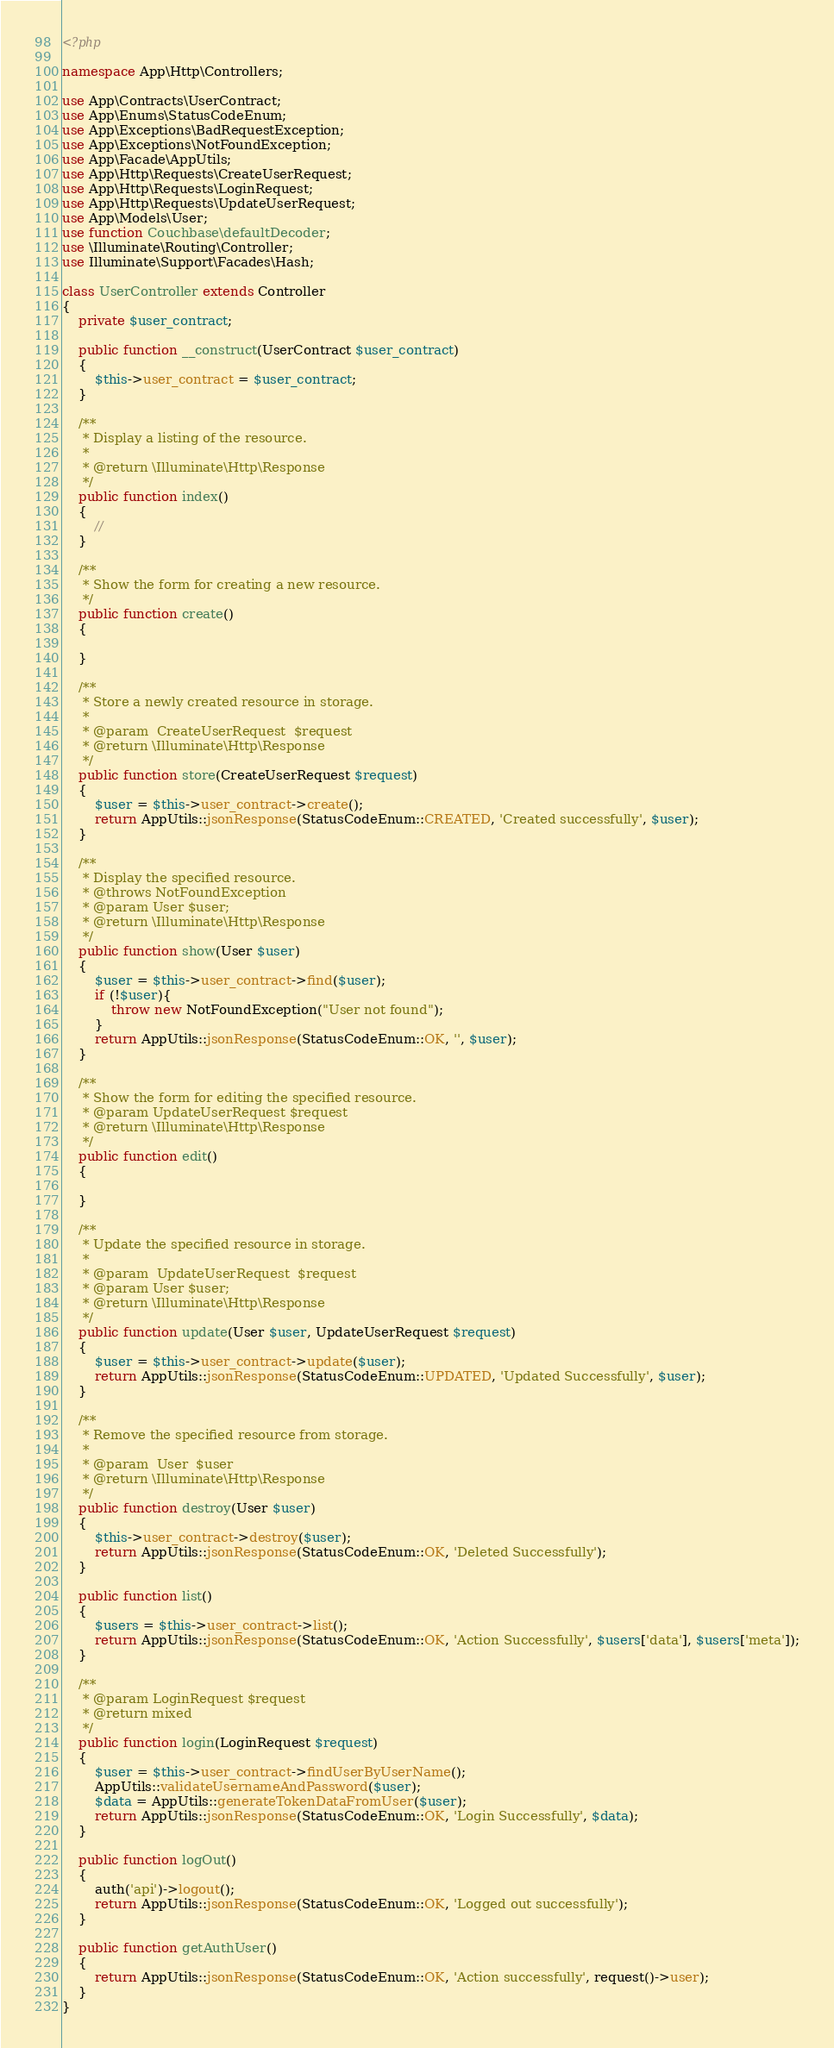Convert code to text. <code><loc_0><loc_0><loc_500><loc_500><_PHP_><?php

namespace App\Http\Controllers;

use App\Contracts\UserContract;
use App\Enums\StatusCodeEnum;
use App\Exceptions\BadRequestException;
use App\Exceptions\NotFoundException;
use App\Facade\AppUtils;
use App\Http\Requests\CreateUserRequest;
use App\Http\Requests\LoginRequest;
use App\Http\Requests\UpdateUserRequest;
use App\Models\User;
use function Couchbase\defaultDecoder;
use \Illuminate\Routing\Controller;
use Illuminate\Support\Facades\Hash;

class UserController extends Controller
{
    private $user_contract;

    public function __construct(UserContract $user_contract)
    {
        $this->user_contract = $user_contract;
    }

    /**
     * Display a listing of the resource.
     *
     * @return \Illuminate\Http\Response
     */
    public function index()
    {
        //
    }

    /**
     * Show the form for creating a new resource.
     */
    public function create()
    {

    }

    /**
     * Store a newly created resource in storage.
     *
     * @param  CreateUserRequest  $request
     * @return \Illuminate\Http\Response
     */
    public function store(CreateUserRequest $request)
    {
        $user = $this->user_contract->create();
        return AppUtils::jsonResponse(StatusCodeEnum::CREATED, 'Created successfully', $user);
    }

    /**
     * Display the specified resource.
     * @throws NotFoundException
     * @param User $user;
     * @return \Illuminate\Http\Response
     */
    public function show(User $user)
    {
        $user = $this->user_contract->find($user);
        if (!$user){
            throw new NotFoundException("User not found");
        }
        return AppUtils::jsonResponse(StatusCodeEnum::OK, '', $user);
    }

    /**
     * Show the form for editing the specified resource.
     * @param UpdateUserRequest $request
     * @return \Illuminate\Http\Response
     */
    public function edit()
    {

    }

    /**
     * Update the specified resource in storage.
     *
     * @param  UpdateUserRequest  $request
     * @param User $user;
     * @return \Illuminate\Http\Response
     */
    public function update(User $user, UpdateUserRequest $request)
    {
        $user = $this->user_contract->update($user);
        return AppUtils::jsonResponse(StatusCodeEnum::UPDATED, 'Updated Successfully', $user);
    }

    /**
     * Remove the specified resource from storage.
     *
     * @param  User  $user
     * @return \Illuminate\Http\Response
     */
    public function destroy(User $user)
    {
        $this->user_contract->destroy($user);
        return AppUtils::jsonResponse(StatusCodeEnum::OK, 'Deleted Successfully');
    }

    public function list()
    {
        $users = $this->user_contract->list();
        return AppUtils::jsonResponse(StatusCodeEnum::OK, 'Action Successfully', $users['data'], $users['meta']);
    }

    /**
     * @param LoginRequest $request
     * @return mixed
     */
    public function login(LoginRequest $request)
    {
        $user = $this->user_contract->findUserByUserName();
        AppUtils::validateUsernameAndPassword($user);
        $data = AppUtils::generateTokenDataFromUser($user);
        return AppUtils::jsonResponse(StatusCodeEnum::OK, 'Login Successfully', $data);
    }

    public function logOut()
    {
        auth('api')->logout();
        return AppUtils::jsonResponse(StatusCodeEnum::OK, 'Logged out successfully');
    }

    public function getAuthUser()
    {
        return AppUtils::jsonResponse(StatusCodeEnum::OK, 'Action successfully', request()->user);
    }
}
</code> 